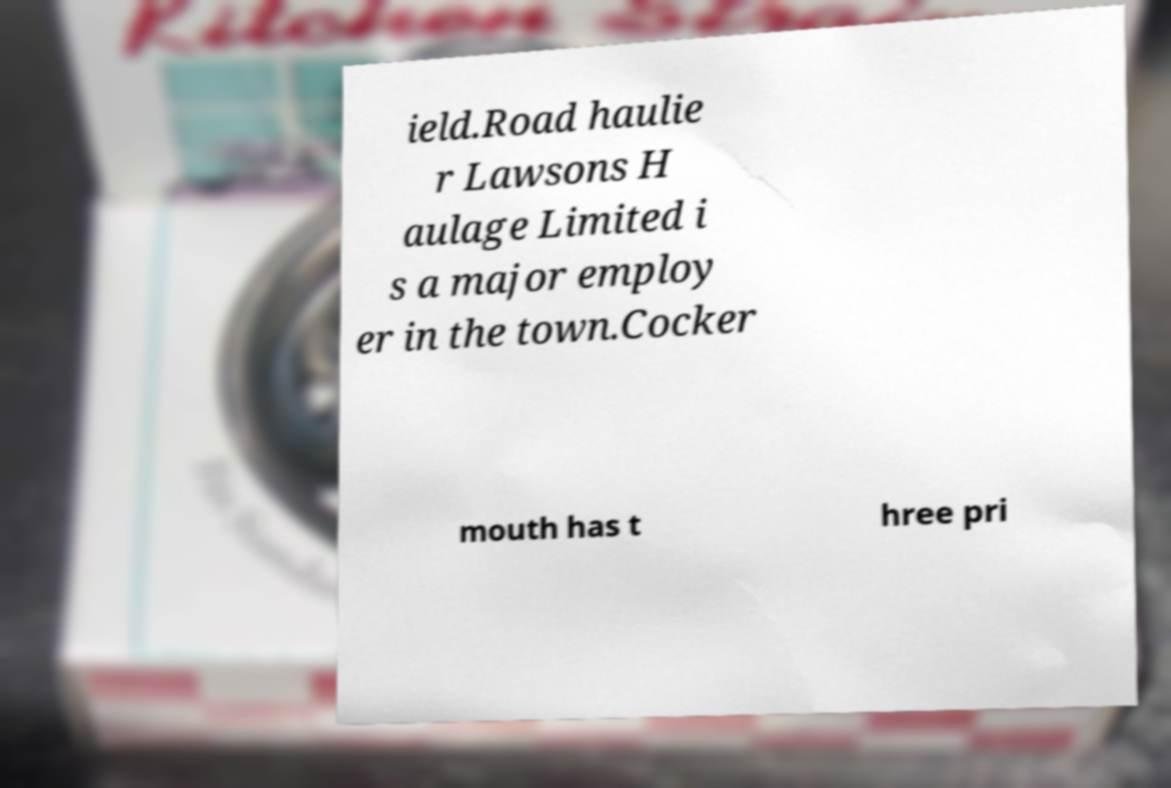There's text embedded in this image that I need extracted. Can you transcribe it verbatim? ield.Road haulie r Lawsons H aulage Limited i s a major employ er in the town.Cocker mouth has t hree pri 